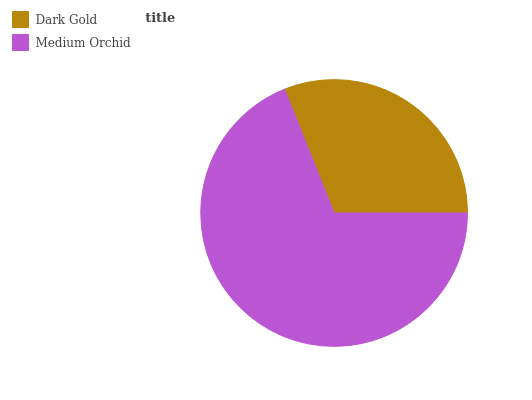Is Dark Gold the minimum?
Answer yes or no. Yes. Is Medium Orchid the maximum?
Answer yes or no. Yes. Is Medium Orchid the minimum?
Answer yes or no. No. Is Medium Orchid greater than Dark Gold?
Answer yes or no. Yes. Is Dark Gold less than Medium Orchid?
Answer yes or no. Yes. Is Dark Gold greater than Medium Orchid?
Answer yes or no. No. Is Medium Orchid less than Dark Gold?
Answer yes or no. No. Is Medium Orchid the high median?
Answer yes or no. Yes. Is Dark Gold the low median?
Answer yes or no. Yes. Is Dark Gold the high median?
Answer yes or no. No. Is Medium Orchid the low median?
Answer yes or no. No. 